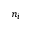Convert formula to latex. <formula><loc_0><loc_0><loc_500><loc_500>n _ { i }</formula> 